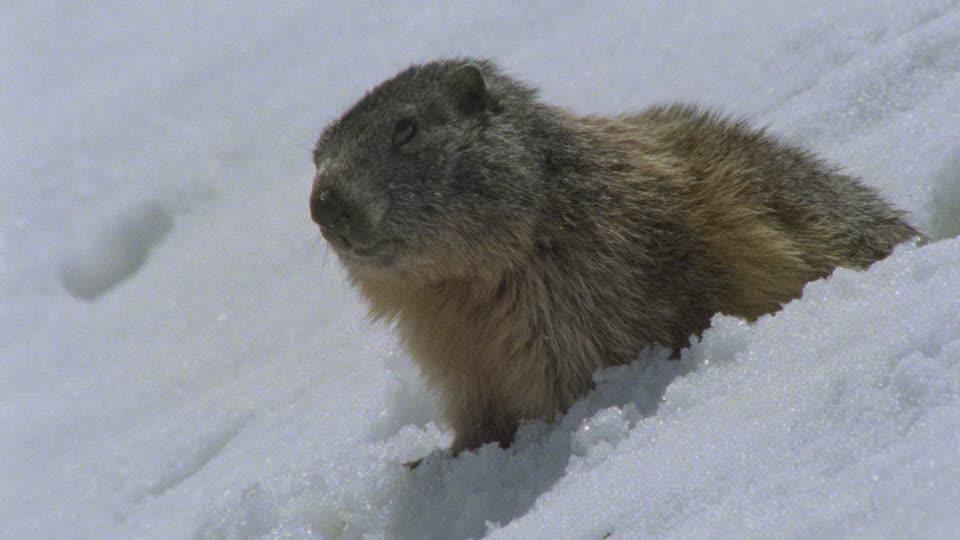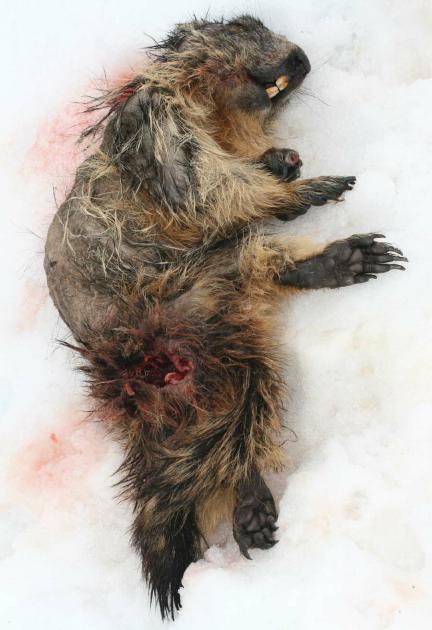The first image is the image on the left, the second image is the image on the right. Given the left and right images, does the statement "An image shows a single close-mouthed marmot poking its head up out of the snow." hold true? Answer yes or no. Yes. The first image is the image on the left, the second image is the image on the right. Examine the images to the left and right. Is the description "The left image contains exactly one rodent in the snow." accurate? Answer yes or no. Yes. 